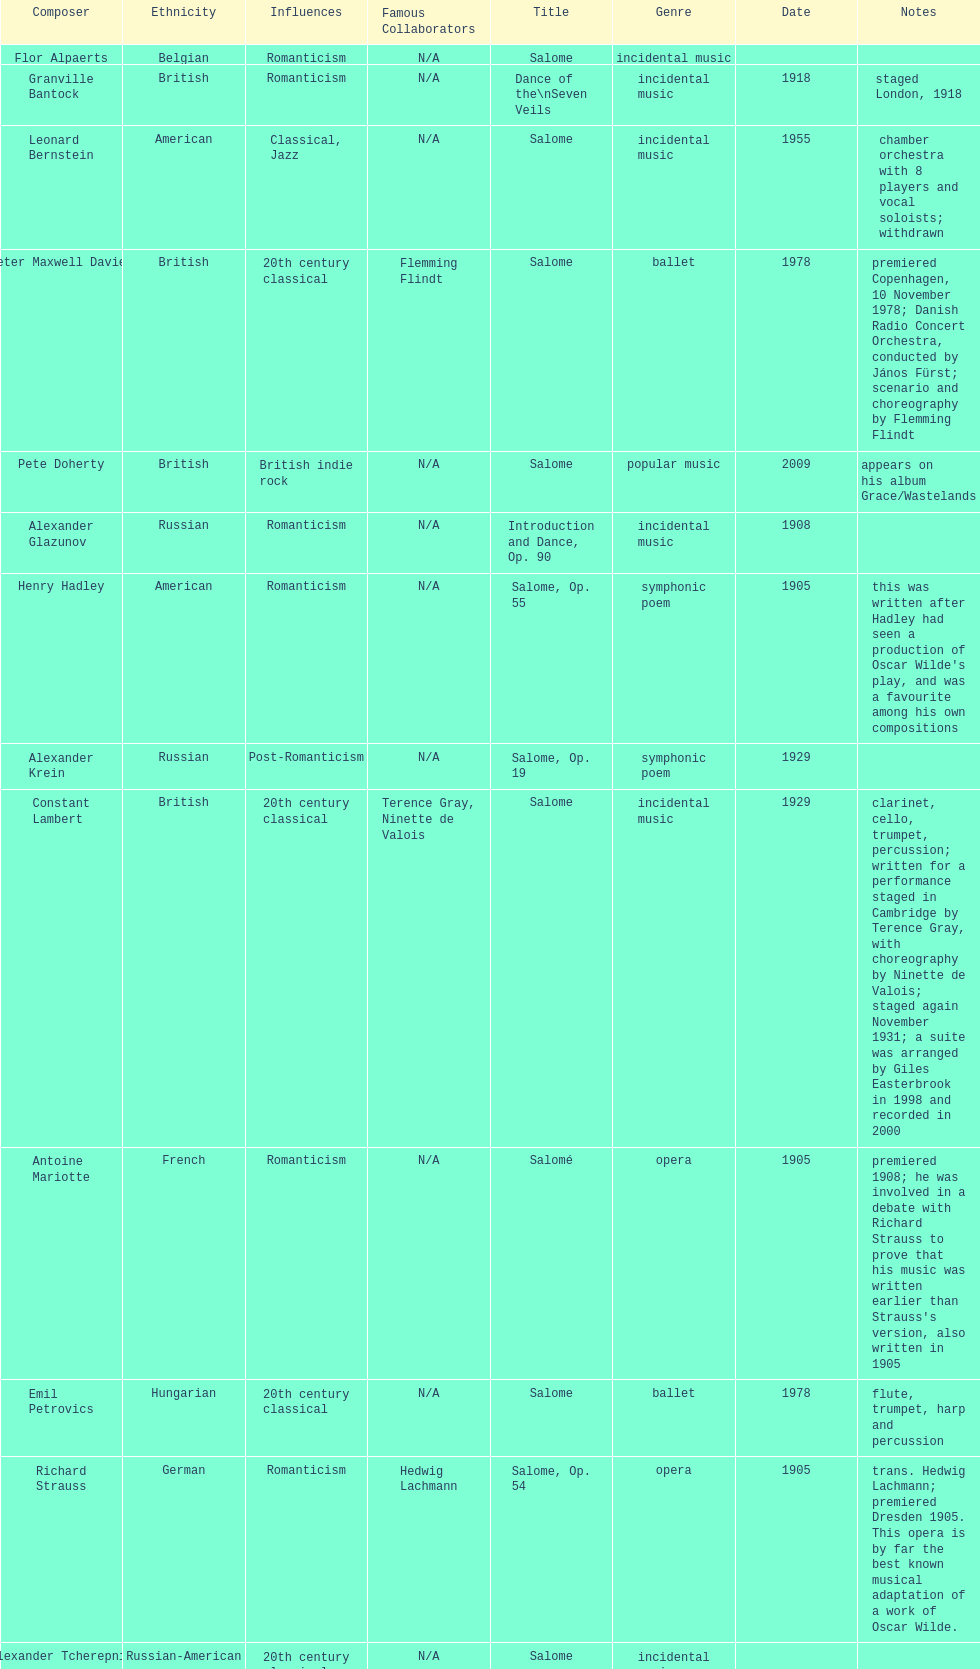How many works were made in the incidental music genre? 6. 